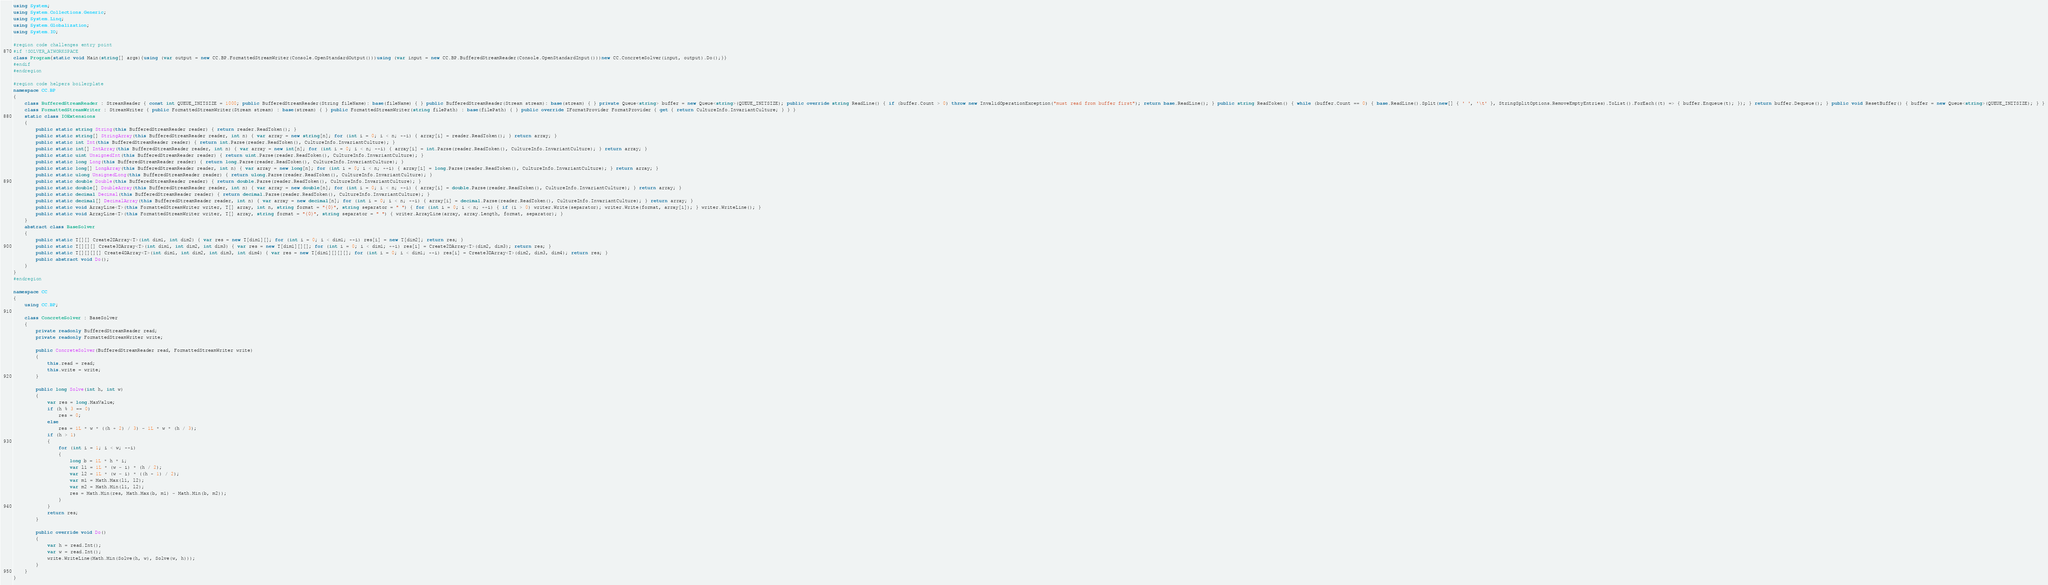Convert code to text. <code><loc_0><loc_0><loc_500><loc_500><_C#_>using System;
using System.Collections.Generic;
using System.Linq;
using System.Globalization;
using System.IO;

#region code challenges entry point
#if !SOLVER_ATWORKSPACE
class Program{static void Main(string[] args){using (var output = new CC.BP.FormattedStreamWriter(Console.OpenStandardOutput()))using (var input = new CC.BP.BufferedStreamReader(Console.OpenStandardInput()))new CC.ConcreteSolver(input, output).Do();}}
#endif
#endregion

#region code helpers boilerplate
namespace CC.BP
{    
    class BufferedStreamReader : StreamReader { const int QUEUE_INITSIZE = 1000; public BufferedStreamReader(String fileName): base(fileName) { } public BufferedStreamReader(Stream stream): base(stream) { } private Queue<string> buffer = new Queue<string>(QUEUE_INITSIZE); public override string ReadLine() { if (buffer.Count > 0) throw new InvalidOperationException("must read from buffer first"); return base.ReadLine(); } public string ReadToken() { while (buffer.Count == 0) { base.ReadLine().Split(new[] { ' ', '\t' }, StringSplitOptions.RemoveEmptyEntries).ToList().ForEach((t) => { buffer.Enqueue(t); }); } return buffer.Dequeue(); } public void ResetBuffer() { buffer = new Queue<string>(QUEUE_INITSIZE); } }
    class FormattedStreamWriter : StreamWriter { public FormattedStreamWriter(Stream stream) : base(stream) { } public FormattedStreamWriter(string filePath) : base(filePath) { } public override IFormatProvider FormatProvider { get { return CultureInfo.InvariantCulture; } } }
    static class IOExtensions
    {
        public static string String(this BufferedStreamReader reader) { return reader.ReadToken(); }
        public static string[] StringArray(this BufferedStreamReader reader, int n) { var array = new string[n]; for (int i = 0; i < n; ++i) { array[i] = reader.ReadToken(); } return array; }
        public static int Int(this BufferedStreamReader reader) { return int.Parse(reader.ReadToken(), CultureInfo.InvariantCulture); }
        public static int[] IntArray(this BufferedStreamReader reader, int n) { var array = new int[n]; for (int i = 0; i < n; ++i) { array[i] = int.Parse(reader.ReadToken(), CultureInfo.InvariantCulture); } return array; }
        public static uint UnsignedInt(this BufferedStreamReader reader) { return uint.Parse(reader.ReadToken(), CultureInfo.InvariantCulture); }
        public static long Long(this BufferedStreamReader reader) { return long.Parse(reader.ReadToken(), CultureInfo.InvariantCulture); }
        public static long[] LongArray(this BufferedStreamReader reader, int n) { var array = new long[n]; for (int i = 0; i < n; ++i) { array[i] = long.Parse(reader.ReadToken(), CultureInfo.InvariantCulture); } return array; }
        public static ulong UnsignedLong(this BufferedStreamReader reader) { return ulong.Parse(reader.ReadToken(), CultureInfo.InvariantCulture); }
        public static double Double(this BufferedStreamReader reader) { return double.Parse(reader.ReadToken(), CultureInfo.InvariantCulture); }
        public static double[] DoubleArray(this BufferedStreamReader reader, int n) { var array = new double[n]; for (int i = 0; i < n; ++i) { array[i] = double.Parse(reader.ReadToken(), CultureInfo.InvariantCulture); } return array; }
        public static decimal Decimal(this BufferedStreamReader reader) { return decimal.Parse(reader.ReadToken(), CultureInfo.InvariantCulture); }
        public static decimal[] DecimalArray(this BufferedStreamReader reader, int n) { var array = new decimal[n]; for (int i = 0; i < n; ++i) { array[i] = decimal.Parse(reader.ReadToken(), CultureInfo.InvariantCulture); } return array; }
        public static void ArrayLine<T>(this FormattedStreamWriter writer, T[] array, int n, string format = "{0}", string separator = " ") { for (int i = 0; i < n; ++i) { if (i > 0) writer.Write(separator); writer.Write(format, array[i]); } writer.WriteLine(); }
        public static void ArrayLine<T>(this FormattedStreamWriter writer, T[] array, string format = "{0}", string separator = " ") { writer.ArrayLine(array, array.Length, format, separator); }
    }
    abstract class BaseSolver
    {
        public static T[][] Create2DArray<T>(int dim1, int dim2) { var res = new T[dim1][]; for (int i = 0; i < dim1; ++i) res[i] = new T[dim2]; return res; }
        public static T[][][] Create3DArray<T>(int dim1, int dim2, int dim3) { var res = new T[dim1][][]; for (int i = 0; i < dim1; ++i) res[i] = Create2DArray<T>(dim2, dim3); return res; }
        public static T[][][][] Create4DArray<T>(int dim1, int dim2, int dim3, int dim4) { var res = new T[dim1][][][]; for (int i = 0; i < dim1; ++i) res[i] = Create3DArray<T>(dim2, dim3, dim4); return res; }
        public abstract void Do();
    }    
}
#endregion

namespace CC
{
    using CC.BP;

    class ConcreteSolver : BaseSolver
    {
        private readonly BufferedStreamReader read;
        private readonly FormattedStreamWriter write;

        public ConcreteSolver(BufferedStreamReader read, FormattedStreamWriter write)
        {
            this.read = read;
            this.write = write;
        }

        public long Solve(int h, int w)
        {
            var res = long.MaxValue;
            if (h % 3 == 0)
                res = 0;
            else
                res = 1L * w * ((h + 2) / 3) - 1L * w * (h / 3);
            if (h > 1)
            {
                for (int i = 1; i < w; ++i)
                {
                    long b = 1L * h * i;
                    var l1 = 1L * (w - i) * (h / 2);
                    var l2 = 1L * (w - i) * ((h + 1) / 2);
                    var m1 = Math.Max(l1, l2);
                    var m2 = Math.Min(l1, l2);
                    res = Math.Min(res, Math.Max(b, m1) - Math.Min(b, m2));
                }
            }
            return res;
        }

        public override void Do()
        {
            var h = read.Int();
            var w = read.Int();
            write.WriteLine(Math.Min(Solve(h, w), Solve(w, h)));
        }
    }
}</code> 